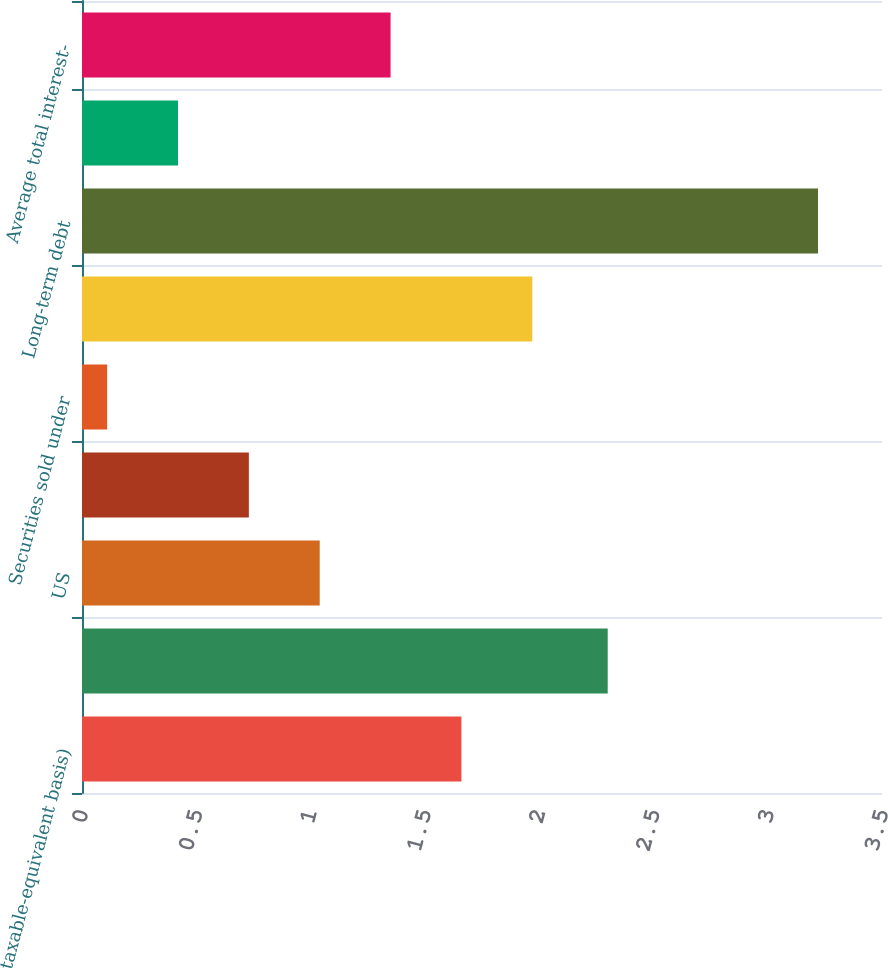Convert chart. <chart><loc_0><loc_0><loc_500><loc_500><bar_chart><fcel>taxable-equivalent basis)<fcel>Loans and leases<fcel>US<fcel>Non-US<fcel>Securities sold under<fcel>Other short-term borrowings<fcel>Long-term debt<fcel>Other interest-bearing<fcel>Average total interest-<nl><fcel>1.66<fcel>2.3<fcel>1.04<fcel>0.73<fcel>0.11<fcel>1.97<fcel>3.22<fcel>0.42<fcel>1.35<nl></chart> 